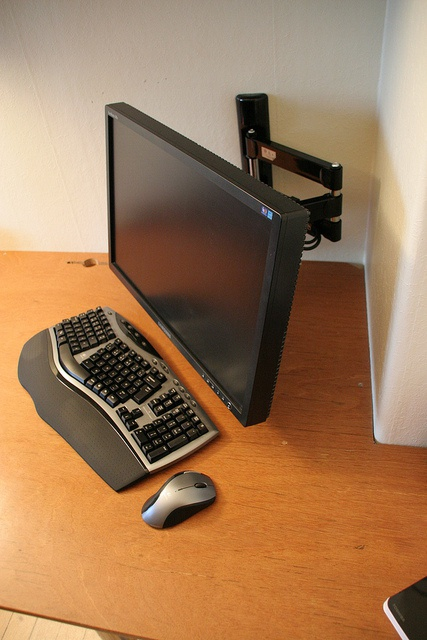Describe the objects in this image and their specific colors. I can see tv in gray, black, and maroon tones, keyboard in gray and black tones, and mouse in gray, black, maroon, and darkgray tones in this image. 